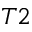<formula> <loc_0><loc_0><loc_500><loc_500>T 2</formula> 